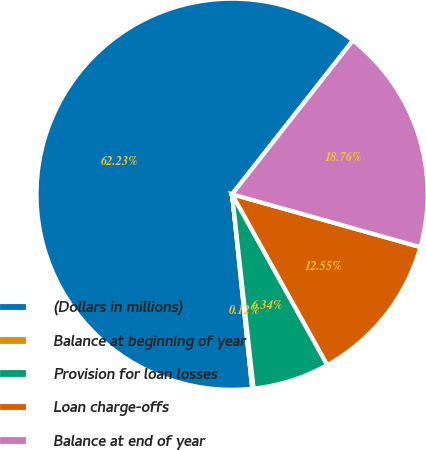Convert chart to OTSL. <chart><loc_0><loc_0><loc_500><loc_500><pie_chart><fcel>(Dollars in millions)<fcel>Balance at beginning of year<fcel>Provision for loan losses<fcel>Loan charge-offs<fcel>Balance at end of year<nl><fcel>62.24%<fcel>0.12%<fcel>6.34%<fcel>12.55%<fcel>18.76%<nl></chart> 